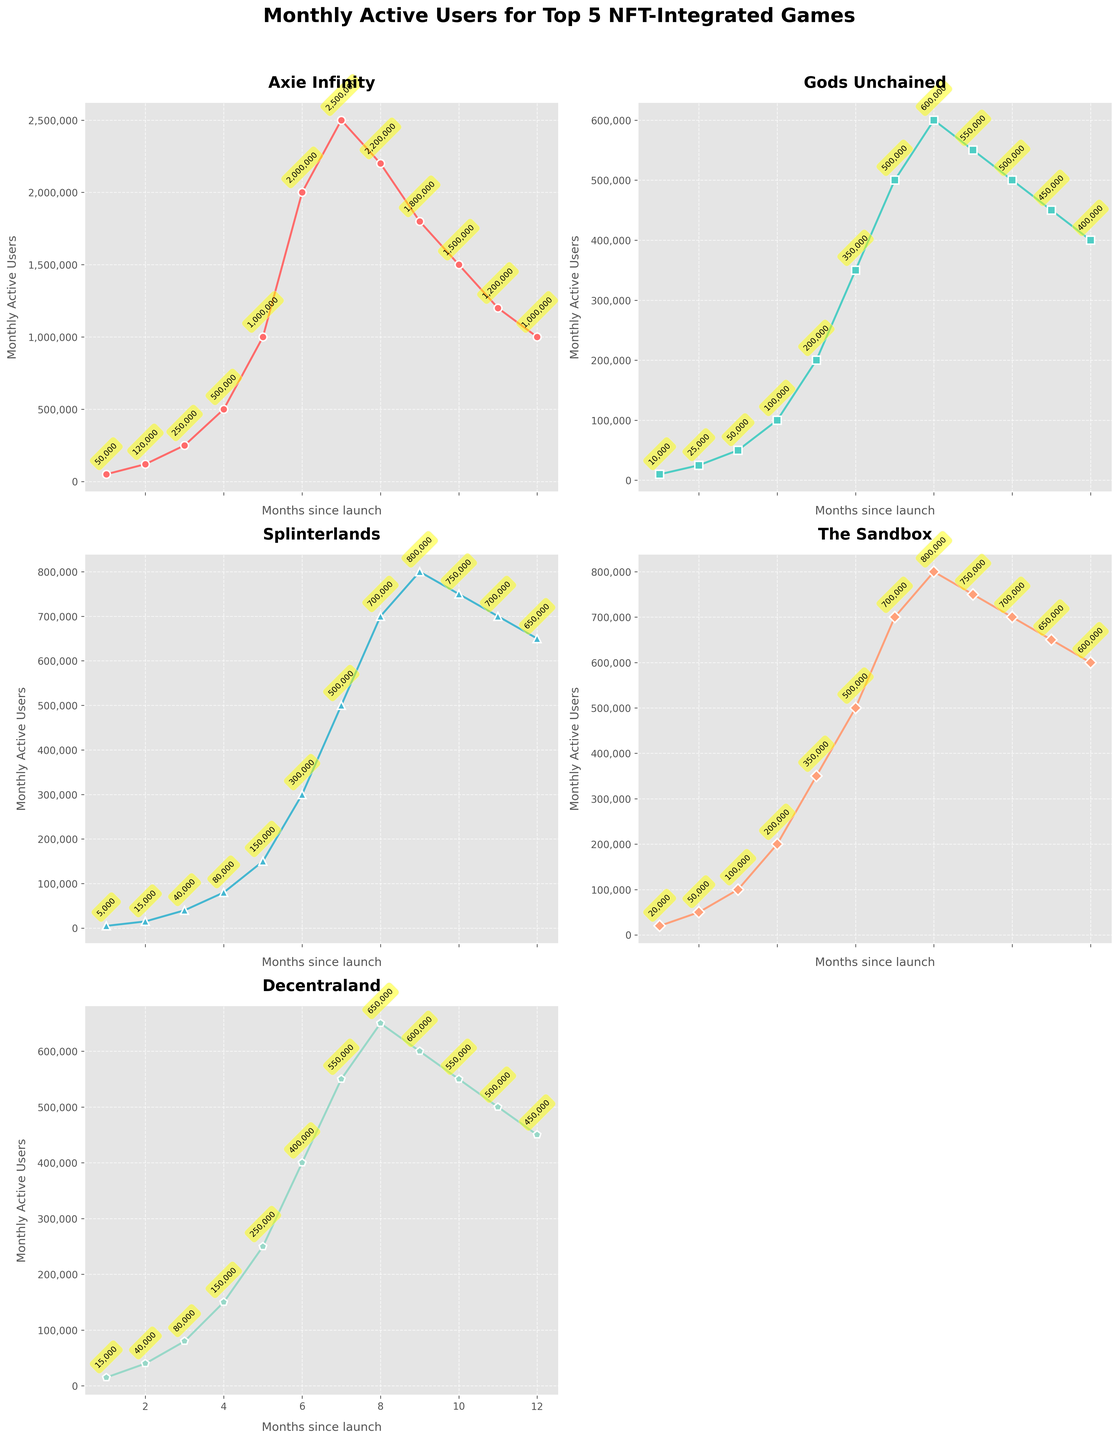What's the initial number of active users for Axie Infinity compared to Gods Unchained? Axie Infinity starts with 50,000 active users in the first month, while Gods Unchained starts with only 10,000. By comparing these values, we see that Axie Infinity starts with a significantly higher user base.
Answer: Axie Infinity has 40,000 more users Which game experienced the highest peak in monthly active users and what was the peak value? By looking at the peak values across all plots, Axie Infinity reached the highest peak with 2,500,000 active users in the seventh month.
Answer: Axie Infinity with 2,500,000 users Between month 6 and month 9, which game showed the most drastic drop in active users and what is the difference? Axie Infinity had a sharp drop from 2,500,000 to 1,800,000 users, a decrease of 700,000 users. This is the most drastic drop among all the games in that period.
Answer: Axie Infinity with a drop of 700,000 users Which game showed continuous growth throughout the 12 months? Both Gods Unchained and Splinterlands show initial continuous growth, but they both plateau towards the end. No game shows continuous growth through all 12 months.
Answer: None How does the finale active user count of The Sandbox compare to Splinterlands? The Sandbox ends with 600,000 active users, while Splinterlands ends with 650,000 active users. Comparing these, The Sandbox has 50,000 fewer active users at the end of the 12 months.
Answer: The Sandbox has 50,000 fewer active users What is the average number of active users for Decentraland in the first six months? Summing the active users for Decentraland in the first six months: 15,000 + 40,000 + 80,000 + 150,000 + 250,000 + 400,000, gives 935,000. Dividing by 6 gives an average of approximately 155,833.
Answer: 155,833 users Which game had the smallest increase in active users from launch (month 1) to month 12? Splinterlands increased from 5,000 to 650,000 users over 12 months, an increase of 645,000 users. This is the smallest increase compared to the other games.
Answer: Splinterlands with an increase of 645,000 users What is the trend observed for active users in Axie Infinity after it peaked in month 7? After peaking at 2,500,000 users in month 7, Axie Infinity shows a declining trend, dropping to 1,000,000 users by month 12. This indicates a significant decrease in active users.
Answer: Declining trend Comparing months 5 and 10, which game shows the most difference in active users and what is that difference? Axie Infinity shows the most difference, dropping from 1,000,000 users in month 5 to 1,500,000 users in month 10, a difference of 500,000 users.
Answer: Axie Infinity with a difference of 500,000 users If you sum the active users for all games in month 1, what is the total number of active users? Summing up the month 1 active users: 50,000 (Axie Infinity) + 10,000 (Gods Unchained) + 5,000 (Splinterlands) + 20,000 (The Sandbox) + 15,000 (Decentraland) gives a total of 100,000 active users.
Answer: 100,000 users 